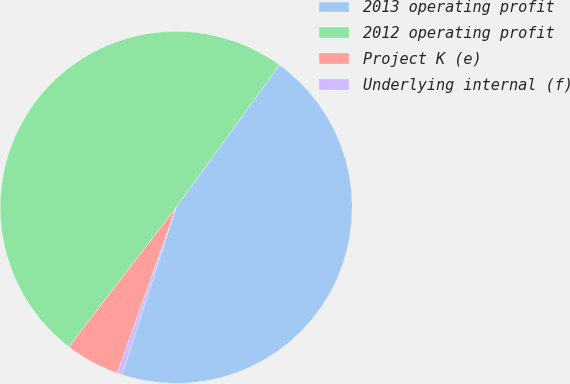<chart> <loc_0><loc_0><loc_500><loc_500><pie_chart><fcel>2013 operating profit<fcel>2012 operating profit<fcel>Project K (e)<fcel>Underlying internal (f)<nl><fcel>45.0%<fcel>49.54%<fcel>5.0%<fcel>0.46%<nl></chart> 